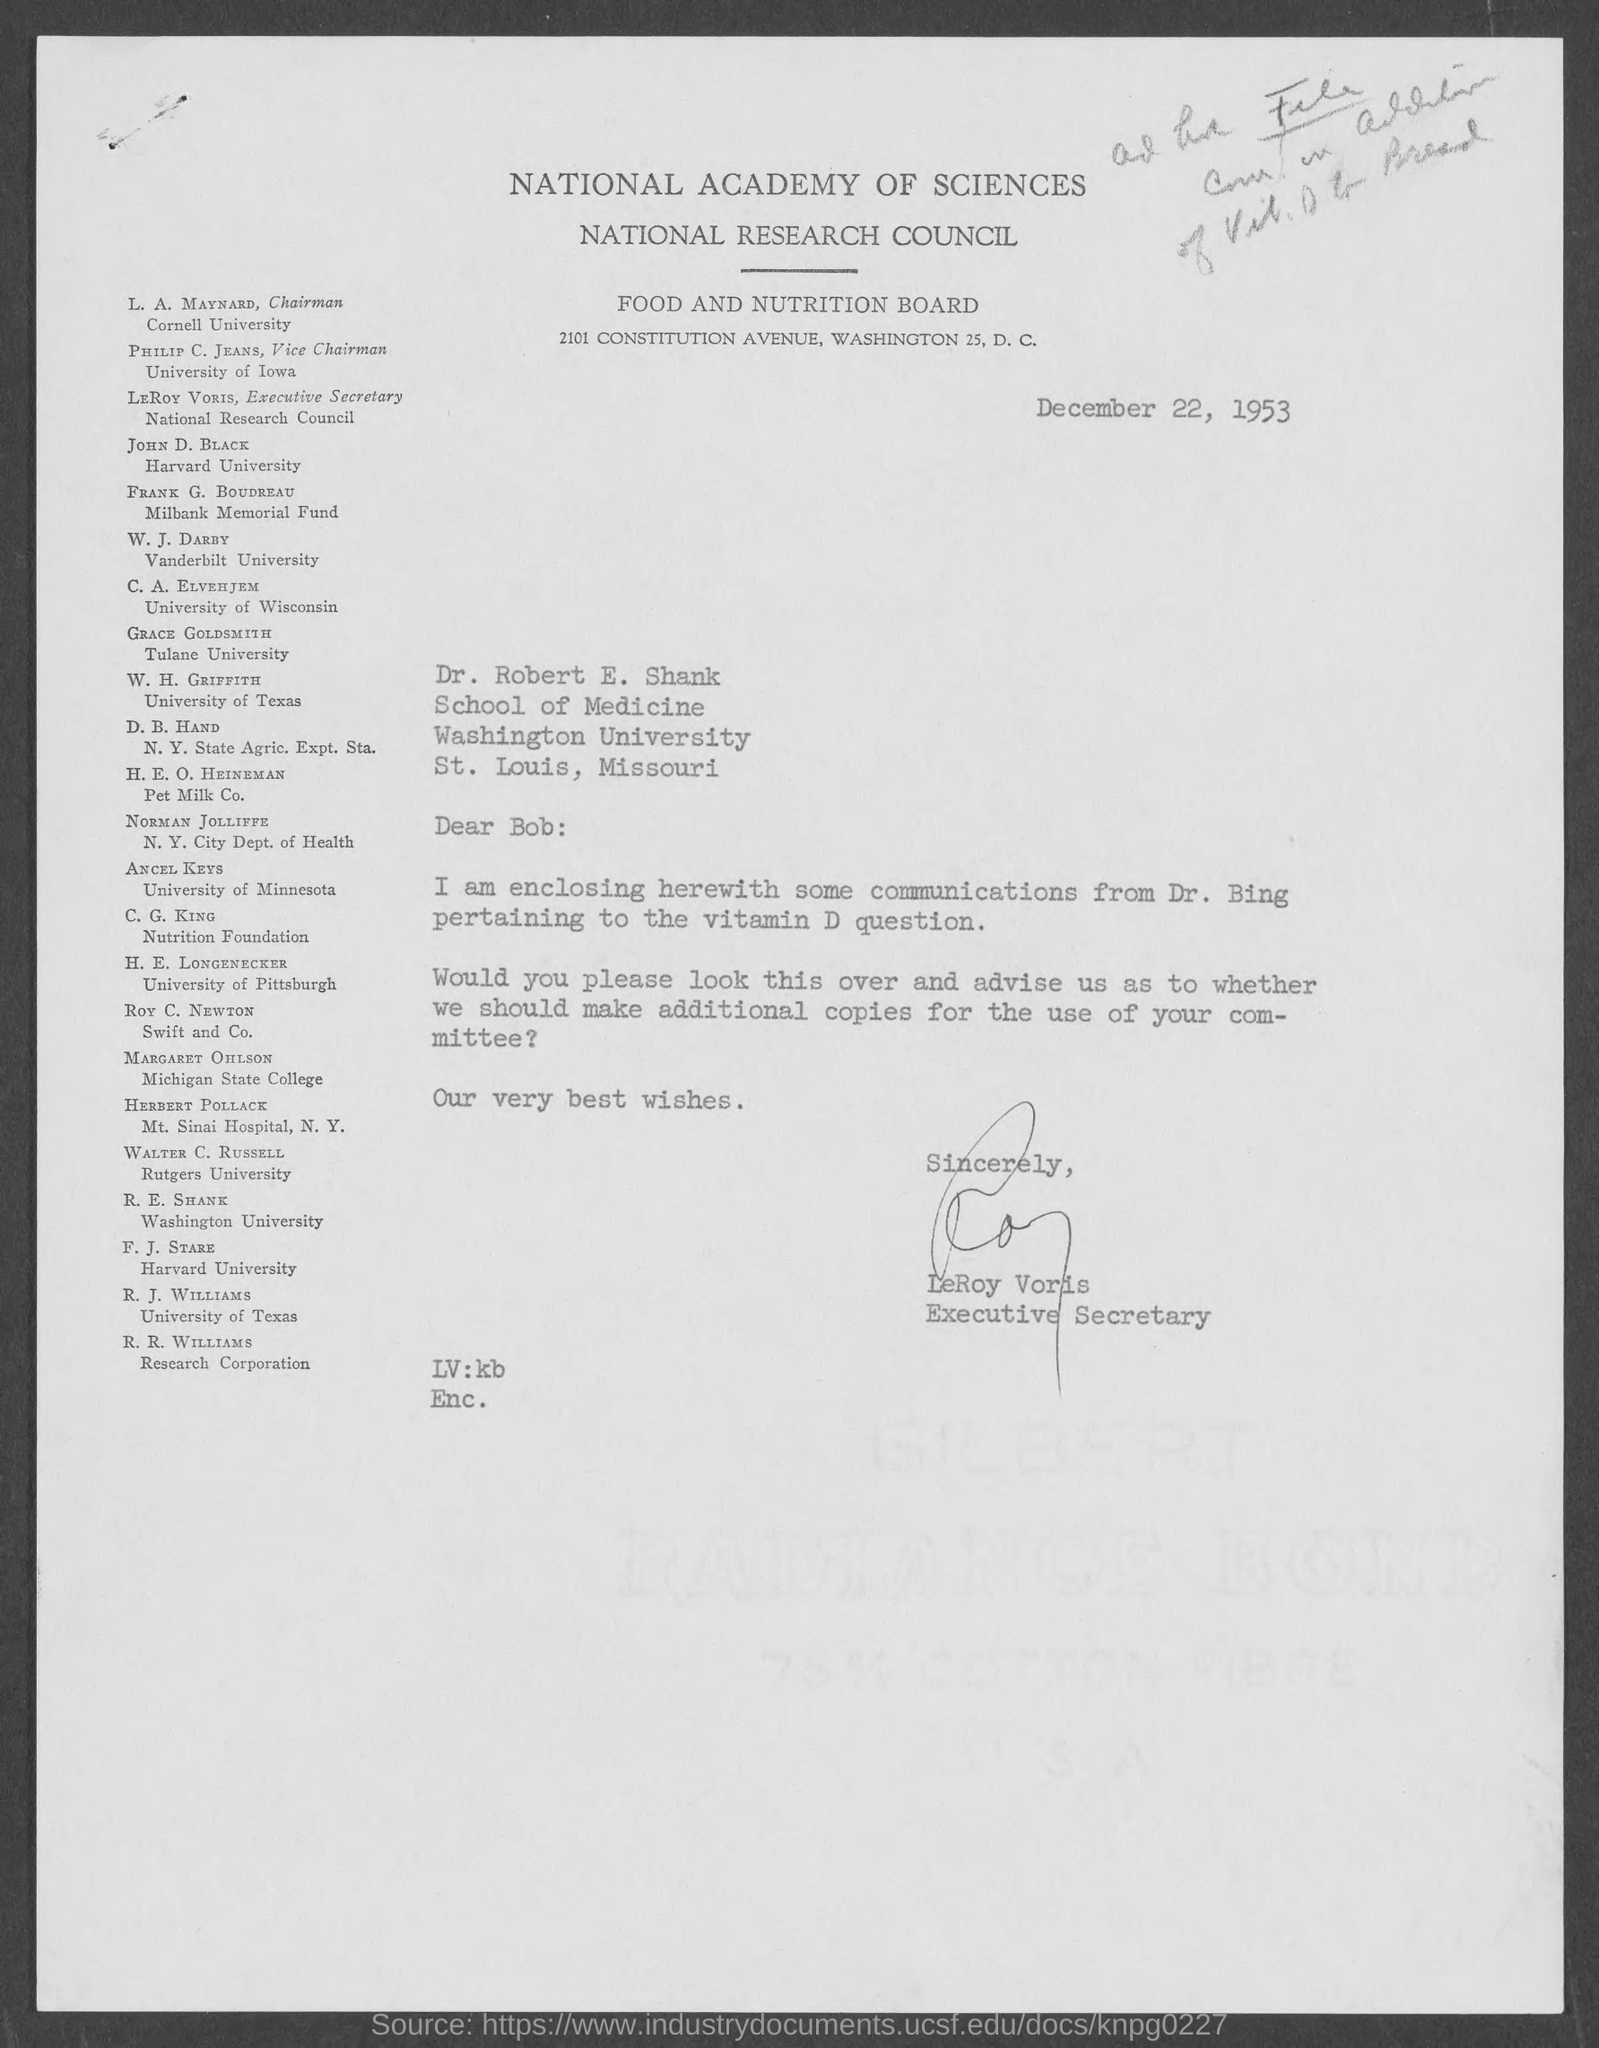Draw attention to some important aspects in this diagram. W. H. Griffith belongs to the University of Texas. William James Darby is affiliated with Vanderbilt University. LeRoy Voris is the Executive Secretary of the National Research Council. C.A. Elvehjem belongs to the University of Wisconsin. Ancel Keys belongs to the University of Minnesota. 